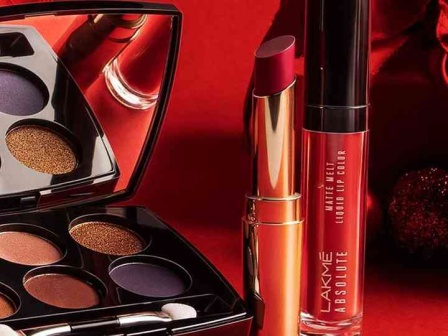What extrinsic factors, like lighting and background, influence the presentation of these makeup products in the advertisement? The use of a vivid red background in this image significantly enhances the visual appeal of the products by contrasting sharply with the gold and purple tones of the makeup, making the products pop visually. Such a backdrop also evokes a feeling of sophistication and passion, aligning with the luxurious and high-quality image of the brand. Additionally, the strategic lighting highlights the shimmer in the eyeshadows and the sheen on the lipsticks, emphasizing texture and color quality, which are crucial for attracting potential customers. 